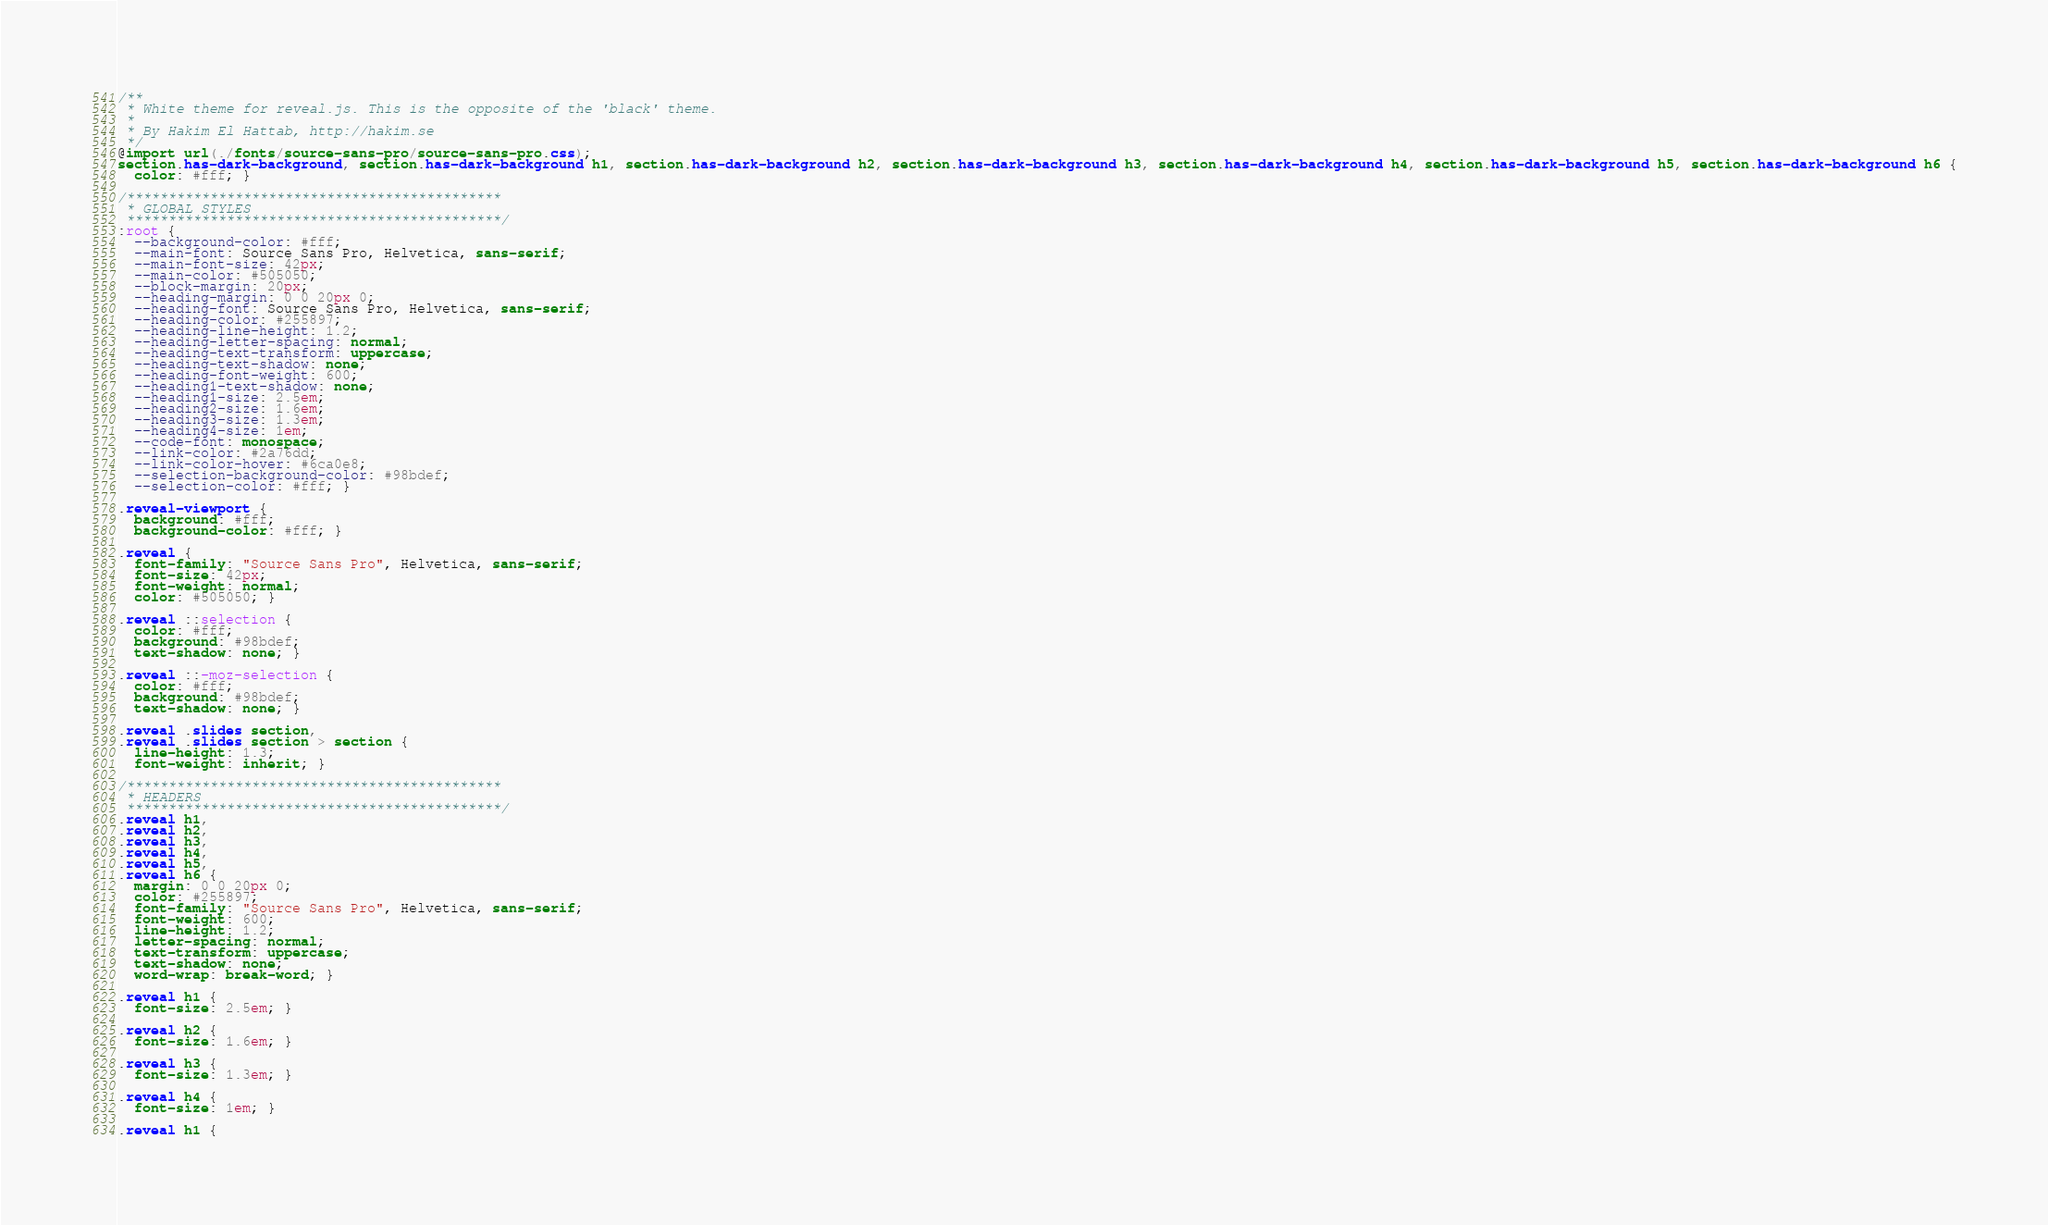Convert code to text. <code><loc_0><loc_0><loc_500><loc_500><_CSS_>/**
 * White theme for reveal.js. This is the opposite of the 'black' theme.
 *
 * By Hakim El Hattab, http://hakim.se
 */
@import url(./fonts/source-sans-pro/source-sans-pro.css);
section.has-dark-background, section.has-dark-background h1, section.has-dark-background h2, section.has-dark-background h3, section.has-dark-background h4, section.has-dark-background h5, section.has-dark-background h6 {
  color: #fff; }

/*********************************************
 * GLOBAL STYLES
 *********************************************/
:root {
  --background-color: #fff;
  --main-font: Source Sans Pro, Helvetica, sans-serif;
  --main-font-size: 42px;
  --main-color: #505050;
  --block-margin: 20px;
  --heading-margin: 0 0 20px 0;
  --heading-font: Source Sans Pro, Helvetica, sans-serif;
  --heading-color: #255897;
  --heading-line-height: 1.2;
  --heading-letter-spacing: normal;
  --heading-text-transform: uppercase;
  --heading-text-shadow: none;
  --heading-font-weight: 600;
  --heading1-text-shadow: none;
  --heading1-size: 2.5em;
  --heading2-size: 1.6em;
  --heading3-size: 1.3em;
  --heading4-size: 1em;
  --code-font: monospace;
  --link-color: #2a76dd;
  --link-color-hover: #6ca0e8;
  --selection-background-color: #98bdef;
  --selection-color: #fff; }

.reveal-viewport {
  background: #fff;
  background-color: #fff; }

.reveal {
  font-family: "Source Sans Pro", Helvetica, sans-serif;
  font-size: 42px;
  font-weight: normal;
  color: #505050; }

.reveal ::selection {
  color: #fff;
  background: #98bdef;
  text-shadow: none; }

.reveal ::-moz-selection {
  color: #fff;
  background: #98bdef;
  text-shadow: none; }

.reveal .slides section,
.reveal .slides section > section {
  line-height: 1.3;
  font-weight: inherit; }

/*********************************************
 * HEADERS
 *********************************************/
.reveal h1,
.reveal h2,
.reveal h3,
.reveal h4,
.reveal h5,
.reveal h6 {
  margin: 0 0 20px 0;
  color: #255897;
  font-family: "Source Sans Pro", Helvetica, sans-serif;
  font-weight: 600;
  line-height: 1.2;
  letter-spacing: normal;
  text-transform: uppercase;
  text-shadow: none;
  word-wrap: break-word; }

.reveal h1 {
  font-size: 2.5em; }

.reveal h2 {
  font-size: 1.6em; }

.reveal h3 {
  font-size: 1.3em; }

.reveal h4 {
  font-size: 1em; }

.reveal h1 {</code> 